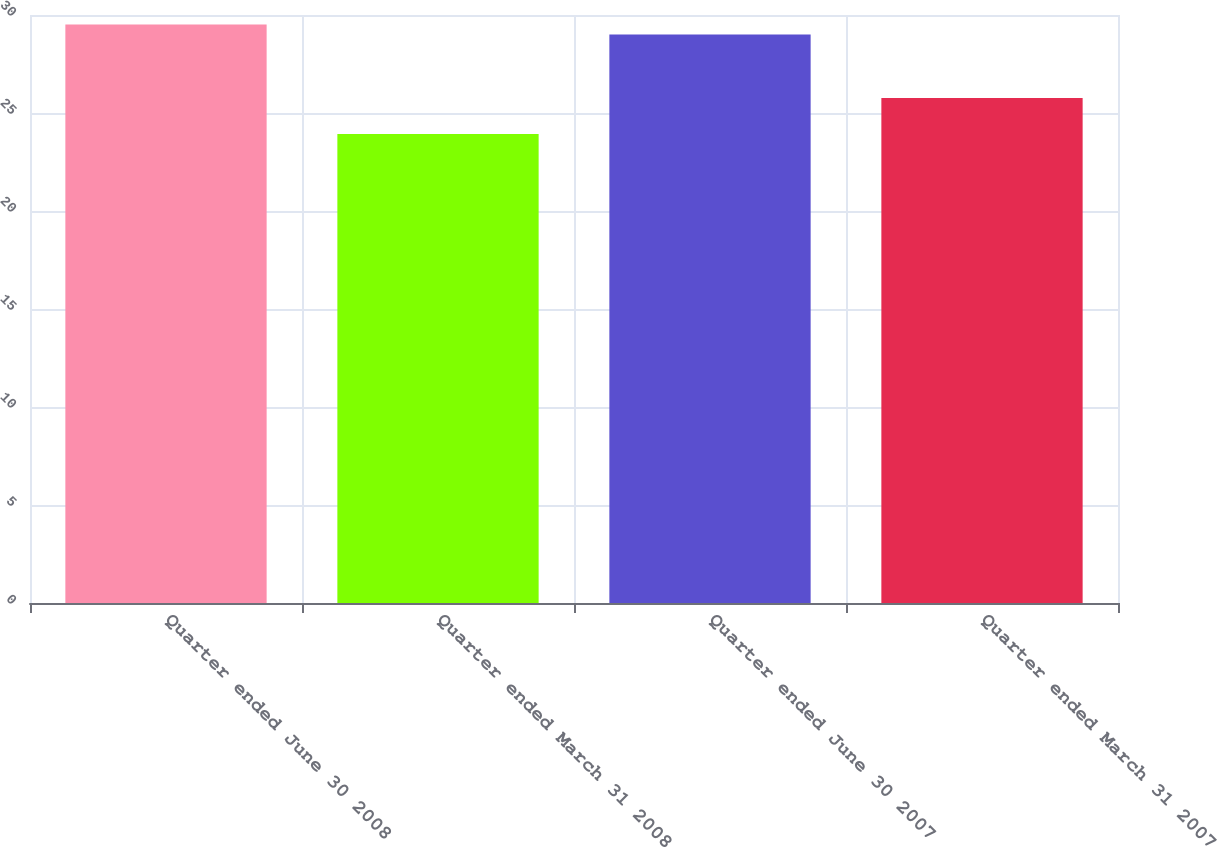Convert chart. <chart><loc_0><loc_0><loc_500><loc_500><bar_chart><fcel>Quarter ended June 30 2008<fcel>Quarter ended March 31 2008<fcel>Quarter ended June 30 2007<fcel>Quarter ended March 31 2007<nl><fcel>29.51<fcel>23.93<fcel>29<fcel>25.76<nl></chart> 